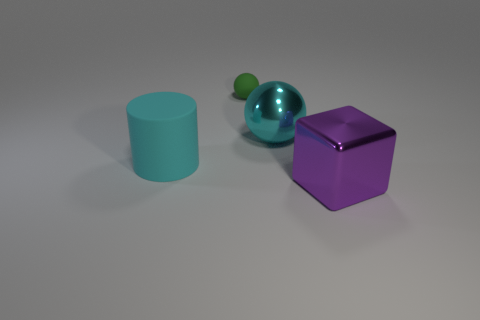Subtract all green balls. How many balls are left? 1 Add 4 big blocks. How many objects exist? 8 Subtract 1 cylinders. How many cylinders are left? 0 Subtract all blocks. How many objects are left? 3 Subtract all yellow blocks. How many green balls are left? 1 Subtract all large cyan objects. Subtract all matte cylinders. How many objects are left? 1 Add 4 big cyan matte things. How many big cyan matte things are left? 5 Add 4 cyan things. How many cyan things exist? 6 Subtract 0 brown blocks. How many objects are left? 4 Subtract all red spheres. Subtract all green blocks. How many spheres are left? 2 